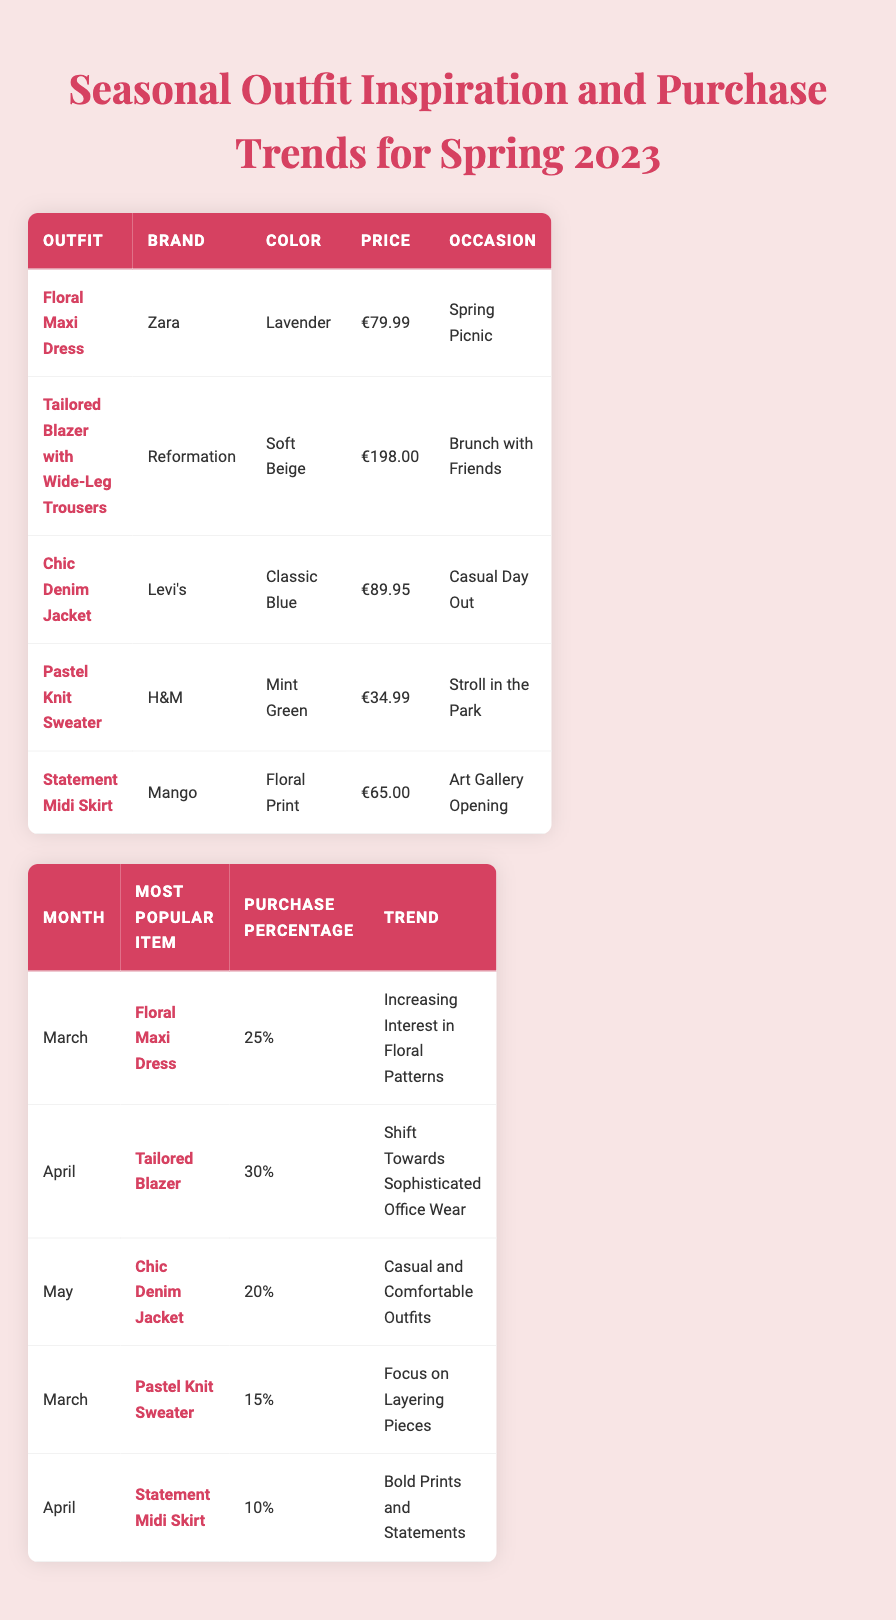What is the most popular item in March 2023? According to the table, the most popular item for March is the **Floral Maxi Dress**, as stated in the Purchase Trends section.
Answer: Floral Maxi Dress Which outfit has the highest price? The **Tailored Blazer with Wide-Leg Trousers** is the most expensive outfit at a price of €198.00 among the Seasonal Outfit Inspiration section.
Answer: Tailored Blazer with Wide-Leg Trousers In which month was the **Statement Midi Skirt** the most purchased item? The **Statement Midi Skirt** was most popular in April 2023, as indicated in the Purchase Trends section.
Answer: April What color is the **Chic Denim Jacket**? The **Chic Denim Jacket** is in **Classic Blue**, as provided in the Seasonal Outfit Inspiration section.
Answer: Classic Blue What was the purchase percentage for the **Pastel Knit Sweater** in March? The purchase percentage for the **Pastel Knit Sweater** in March is 15%, as shown in the Purchase Trends table.
Answer: 15% Which two outfits are popular in April? In April, the popular items were the **Tailored Blazer** and the **Statement Midi Skirt**. These are listed in the Purchase Trends section for that month.
Answer: Tailored Blazer, Statement Midi Skirt What's the average price of the outfits listed in the Seasonal Outfit Inspiration? The prices of the outfits are €79.99, €198.00, €89.95, €34.99, and €65.00. Summing these gives €467.93, and dividing by 5 outfits gives an average price of €93.59.
Answer: €93.59 What trend accompanies the **Chic Denim Jacket**? The trend noted for the **Chic Denim Jacket** is "Casual and Comfortable Outfits," which is mentioned alongside its popularity in the month it was purchased most.
Answer: Casual and Comfortable Outfits Was there a month where the **Pastel Knit Sweater** was the most popular item? Yes, in March 2023, the **Pastel Knit Sweater** ranked as one of the most popular items based on the table data.
Answer: Yes What is the total purchase percentage for March's styles? The total purchase percentage for March styles is calculated as 25% (Floral Maxi Dress) + 15% (Pastel Knit Sweater) = 40%.
Answer: 40% 